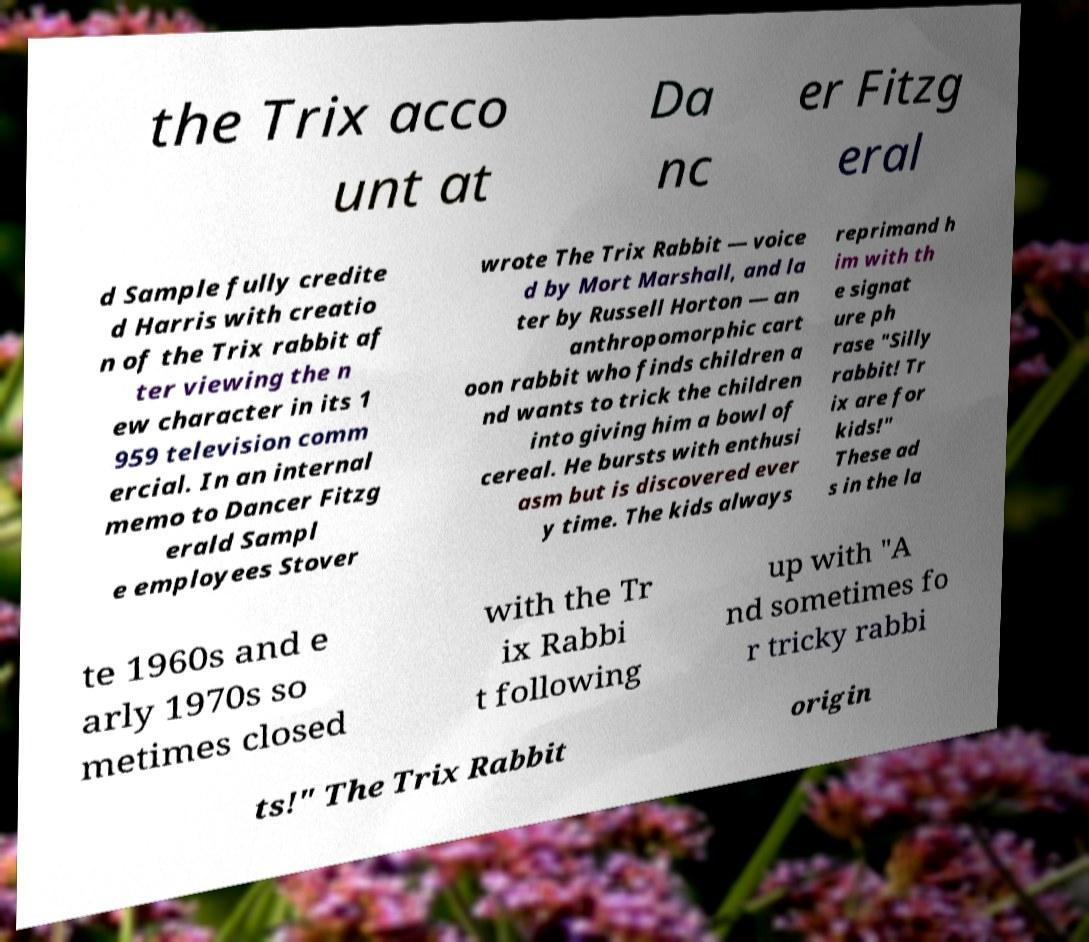Can you read and provide the text displayed in the image?This photo seems to have some interesting text. Can you extract and type it out for me? the Trix acco unt at Da nc er Fitzg eral d Sample fully credite d Harris with creatio n of the Trix rabbit af ter viewing the n ew character in its 1 959 television comm ercial. In an internal memo to Dancer Fitzg erald Sampl e employees Stover wrote The Trix Rabbit — voice d by Mort Marshall, and la ter by Russell Horton — an anthropomorphic cart oon rabbit who finds children a nd wants to trick the children into giving him a bowl of cereal. He bursts with enthusi asm but is discovered ever y time. The kids always reprimand h im with th e signat ure ph rase "Silly rabbit! Tr ix are for kids!" These ad s in the la te 1960s and e arly 1970s so metimes closed with the Tr ix Rabbi t following up with "A nd sometimes fo r tricky rabbi ts!" The Trix Rabbit origin 